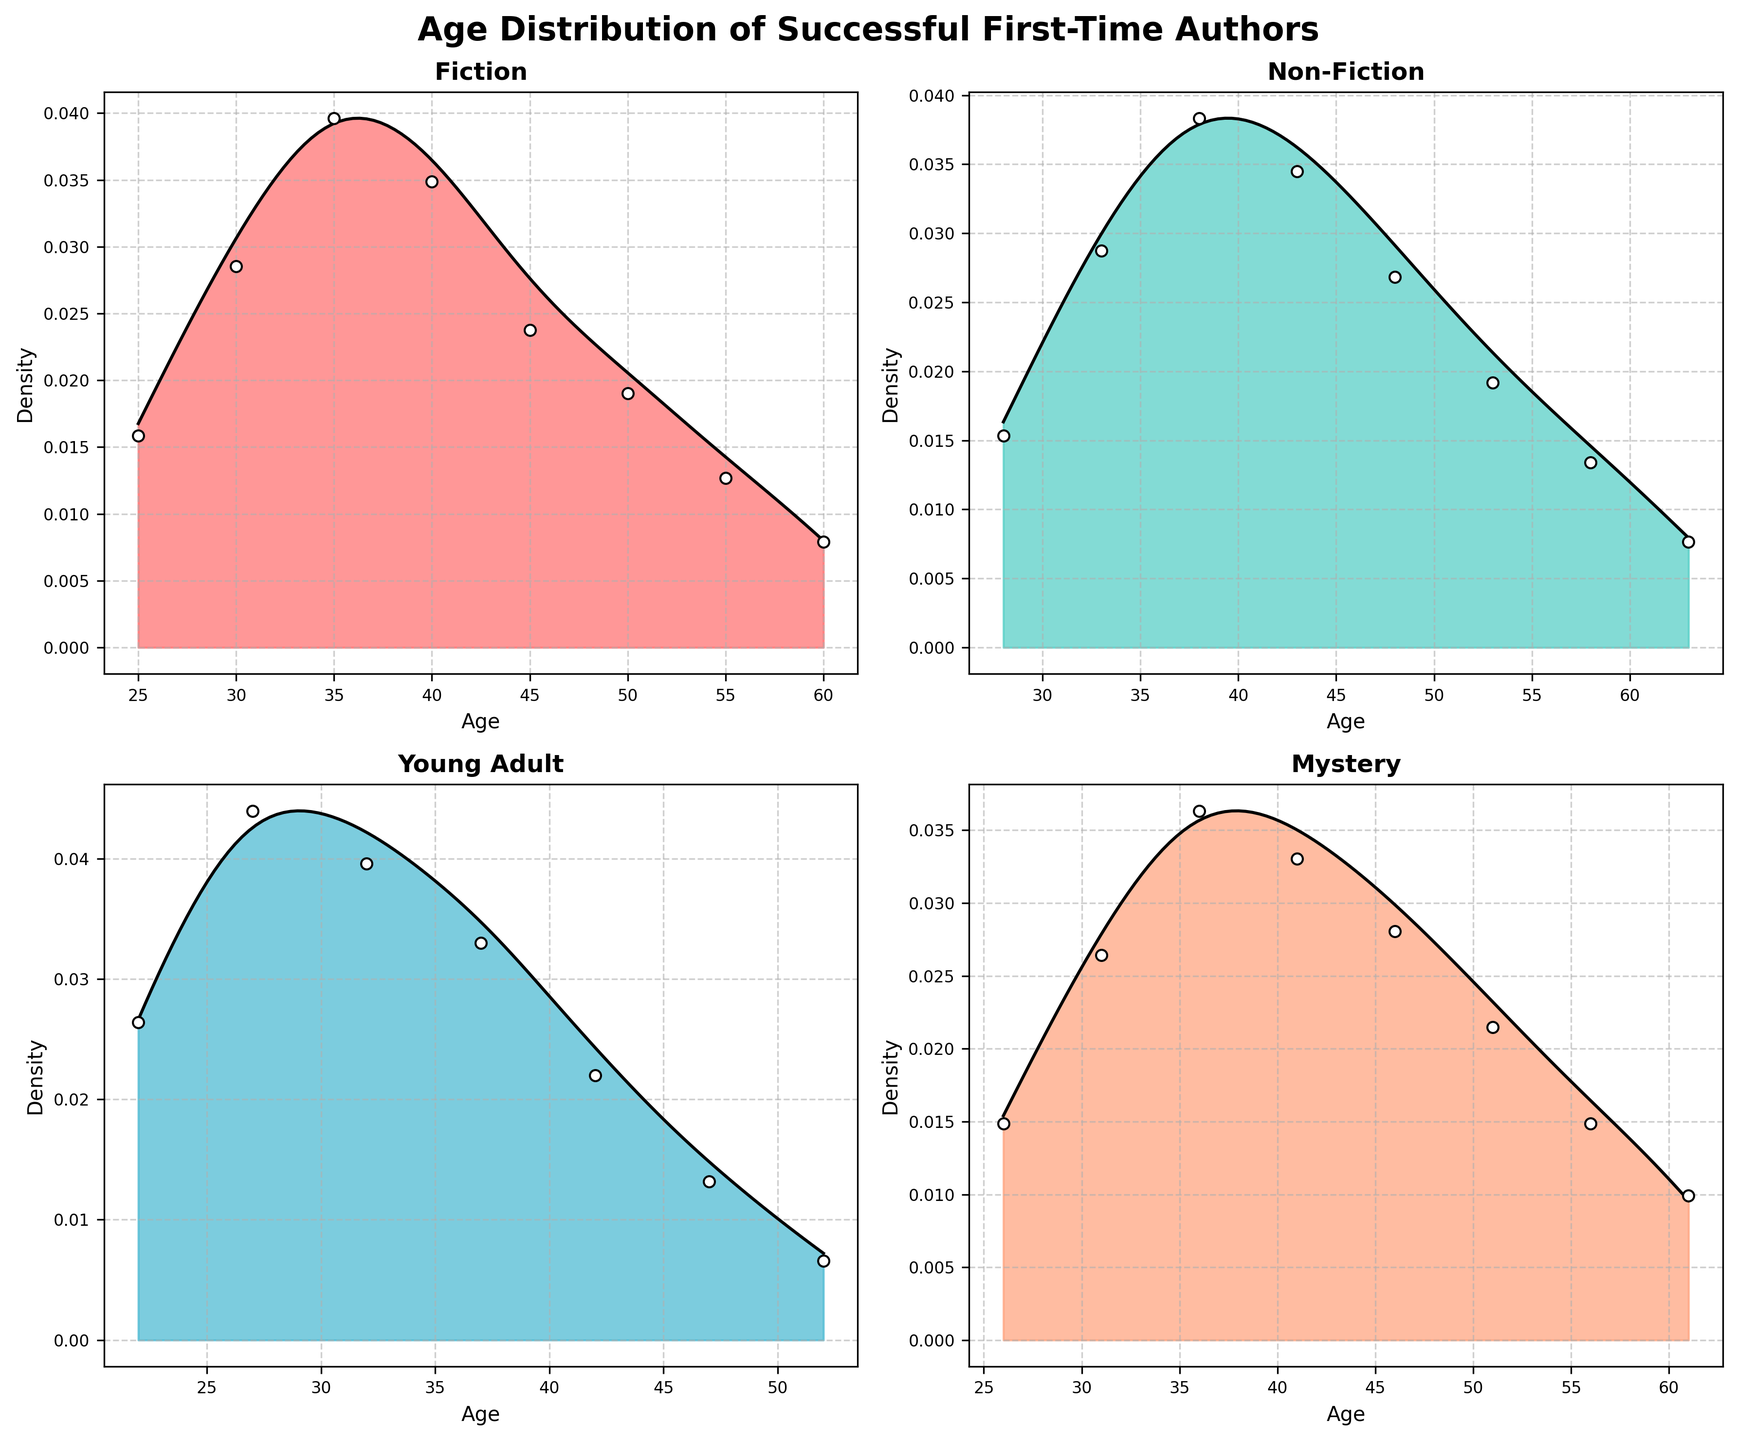What is the title of the figure? The title is the text at the top of the figure that summarizes its content. In this case, it provides an overview of what the plot represents.
Answer: Age Distribution of Successful First-Time Authors Which category has the highest density peak? The category with the highest density peak can be seen by identifying the subplot where the peak in the density curve is the highest.
Answer: Fiction Approximately at what age is the peak density for Non-Fiction authors? Look at the Non-Fiction subplot and find the age where the density curve reaches its maximum.
Answer: Around 38 Which category shows a noticeable peak at a younger age group below 30? The density plot for the category with a peak below 30 will have a prominent rise in the younger age range.
Answer: Young Adult Which category has the lowest density peak value? To determine this, compare the highest points of the density curves across all categories.
Answer: Mystery How does the author distribution in Mystery compare to that in Fiction? Compare the density plots in the Mystery and Fiction subplots. Note the shape, height, and spread of the curves.
Answer: Fiction has a higher density peak and a wider spread Which category shows the most evenly spread density over a range of ages? Look for a density plot with a relatively flat curve covering a broad age range.
Answer: Mystery At what age range do Fiction and Young Adult density plots overlap most closely? Find the segment of the x-axis where both the Fiction and Young Adult density curves are close in value.
Answer: Around age 35 Which two categories exhibit the most similar density patterns? Compare the shapes and peaks of the density curves to identify the two most similar-looking plots.
Answer: Fiction and Non-Fiction What could be inferred about the age diversity among successful first-time authors in Young Adult compared to others? Notice how spread out the density plot for Young Adult is compared to the others; a more spread-out curve indicates higher age diversity.
Answer: Less age diversity 